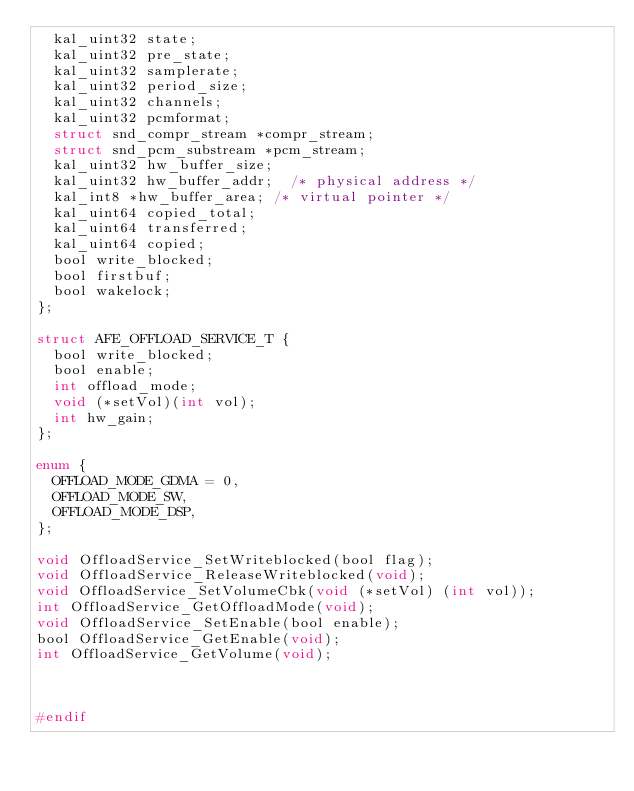Convert code to text. <code><loc_0><loc_0><loc_500><loc_500><_C_>	kal_uint32 state;
	kal_uint32 pre_state;
	kal_uint32 samplerate;
	kal_uint32 period_size;
	kal_uint32 channels;
	kal_uint32 pcmformat;
	struct snd_compr_stream *compr_stream;
	struct snd_pcm_substream *pcm_stream;
	kal_uint32 hw_buffer_size;
	kal_uint32 hw_buffer_addr;	/* physical address */
	kal_int8 *hw_buffer_area;	/* virtual pointer */
	kal_uint64 copied_total;
	kal_uint64 transferred;
	kal_uint64 copied;
	bool write_blocked;
	bool firstbuf;
	bool wakelock;
};

struct AFE_OFFLOAD_SERVICE_T {
	bool write_blocked;
	bool enable;
	int offload_mode;
	void (*setVol)(int vol);
	int hw_gain;
};

enum {
	OFFLOAD_MODE_GDMA = 0,
	OFFLOAD_MODE_SW,
	OFFLOAD_MODE_DSP,
};

void OffloadService_SetWriteblocked(bool flag);
void OffloadService_ReleaseWriteblocked(void);
void OffloadService_SetVolumeCbk(void (*setVol) (int vol));
int OffloadService_GetOffloadMode(void);
void OffloadService_SetEnable(bool enable);
bool OffloadService_GetEnable(void);
int OffloadService_GetVolume(void);



#endif
</code> 